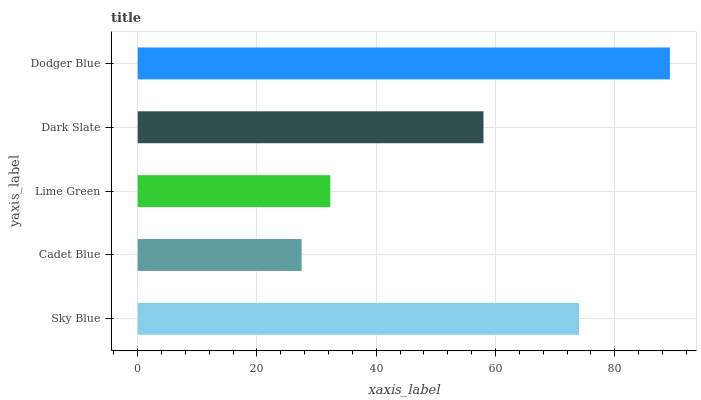Is Cadet Blue the minimum?
Answer yes or no. Yes. Is Dodger Blue the maximum?
Answer yes or no. Yes. Is Lime Green the minimum?
Answer yes or no. No. Is Lime Green the maximum?
Answer yes or no. No. Is Lime Green greater than Cadet Blue?
Answer yes or no. Yes. Is Cadet Blue less than Lime Green?
Answer yes or no. Yes. Is Cadet Blue greater than Lime Green?
Answer yes or no. No. Is Lime Green less than Cadet Blue?
Answer yes or no. No. Is Dark Slate the high median?
Answer yes or no. Yes. Is Dark Slate the low median?
Answer yes or no. Yes. Is Cadet Blue the high median?
Answer yes or no. No. Is Cadet Blue the low median?
Answer yes or no. No. 